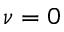<formula> <loc_0><loc_0><loc_500><loc_500>\nu = 0</formula> 